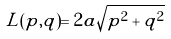Convert formula to latex. <formula><loc_0><loc_0><loc_500><loc_500>L ( p , q ) = 2 a \sqrt { p ^ { 2 } + q ^ { 2 } }</formula> 